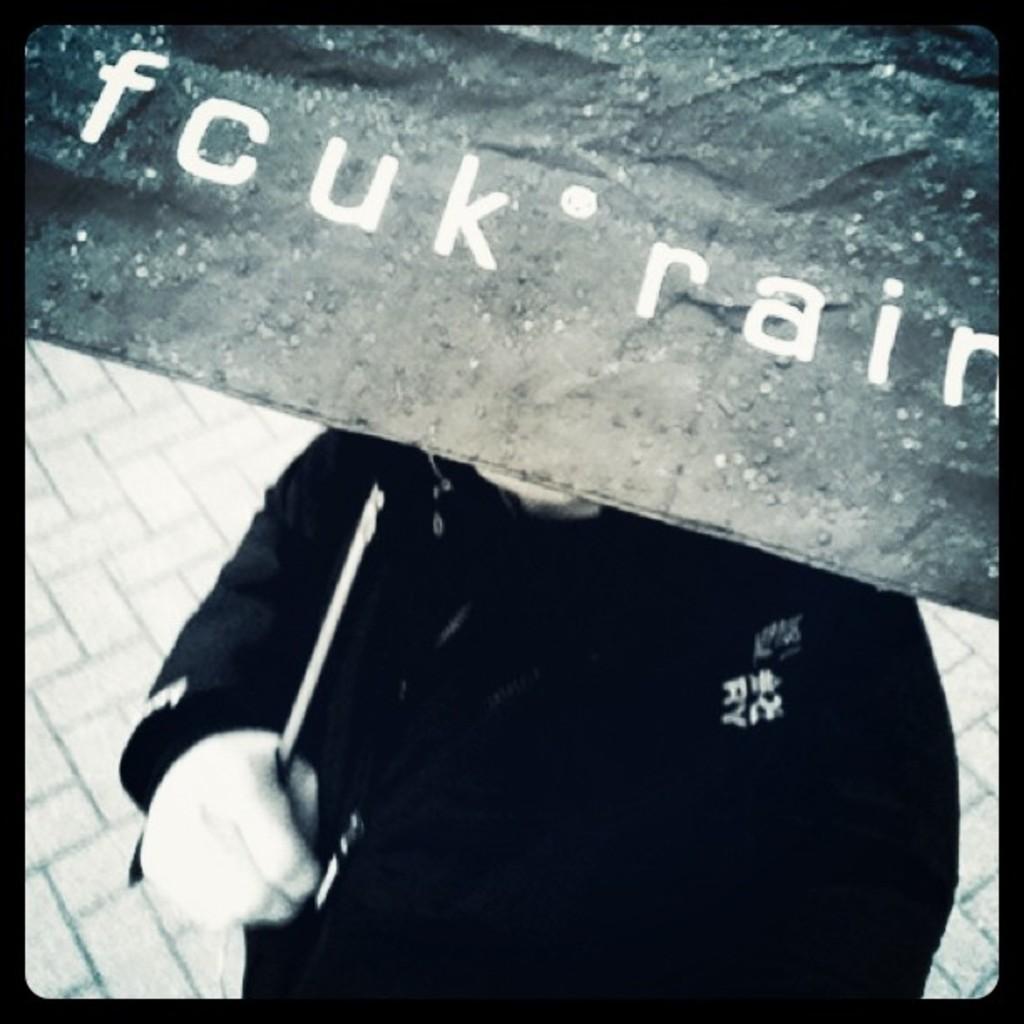How would you summarize this image in a sentence or two? This is a black and white image in which we can see a person holding an umbrella with some text on it. At the bottom of the image there is floor. 